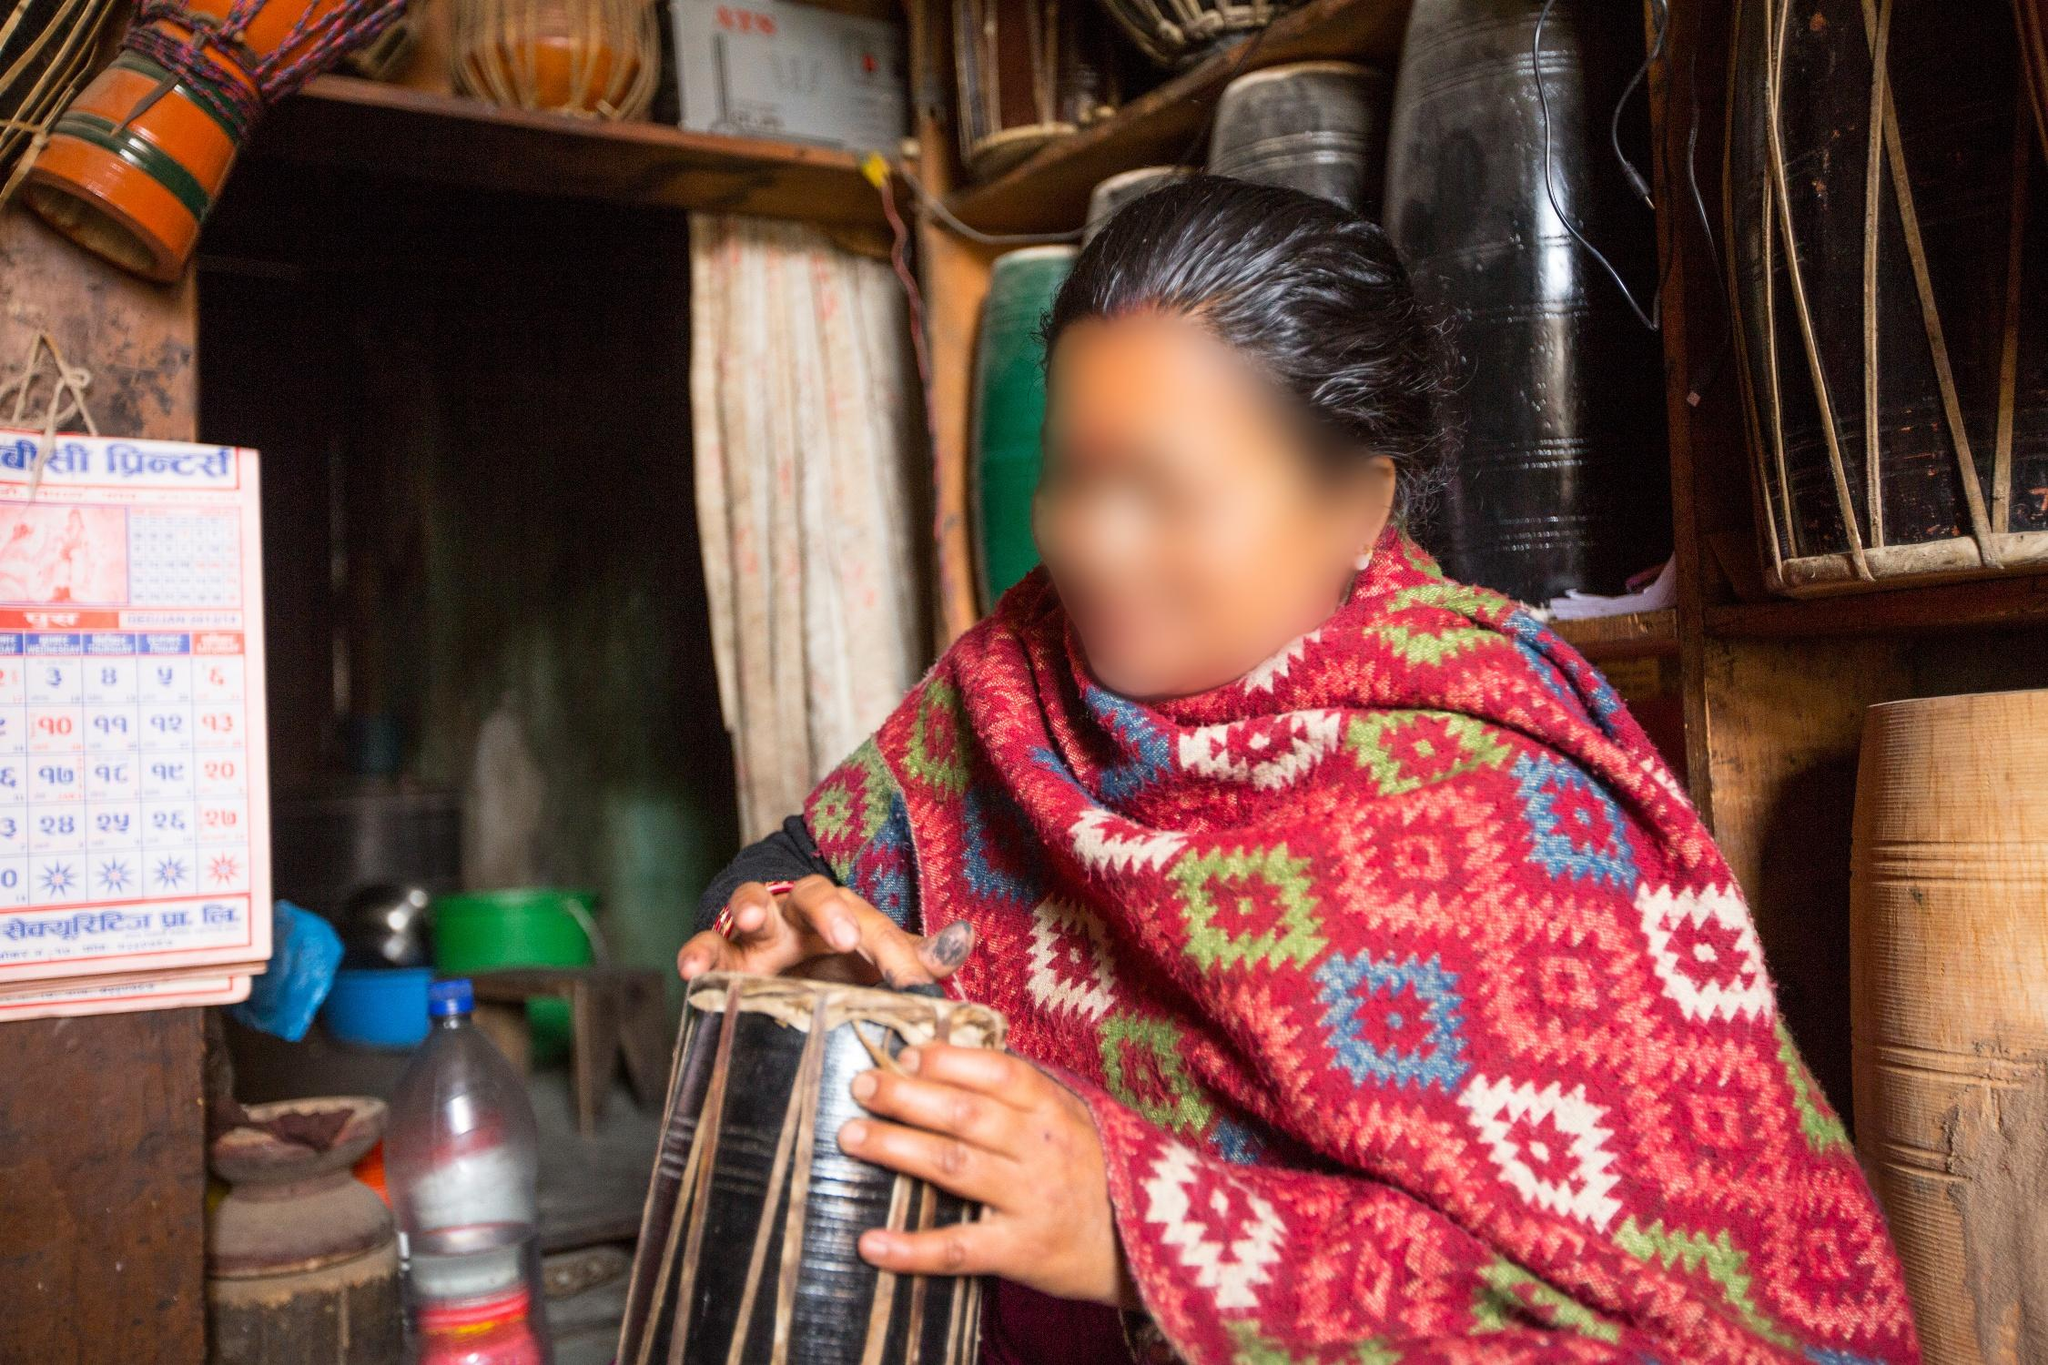What are the key elements in this picture? The image portrays a person seated in a small, cozy shop, deeply engaged in playing a traditional Nepali drum called a madal. The individual is enveloped in a bright, intricately patterned shawl that features a blend of red, pink, and green hues. The shop's shelves behind the person are lined with a variety of items including baskets and pots. A calendar is conspicuously hung on the wall, written in Nepali and reading "वैशाख २०७८", which translates to "April 2021". The person's face is intentionally blurred to protect their privacy. The overall scene encapsulates a harmonious blend of daily life and cultural heritage, highlighted by the presence of traditional music and vibrant attire. 